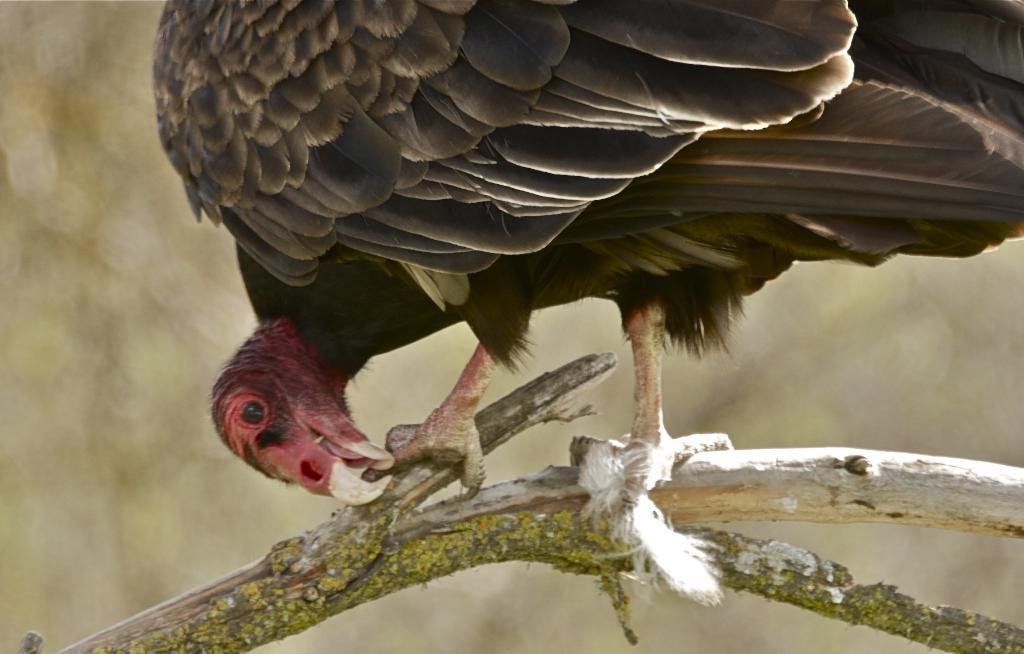Could you give a brief overview of what you see in this image? In this image there is a bird standing on the branch of a tree and the background is blurry. 